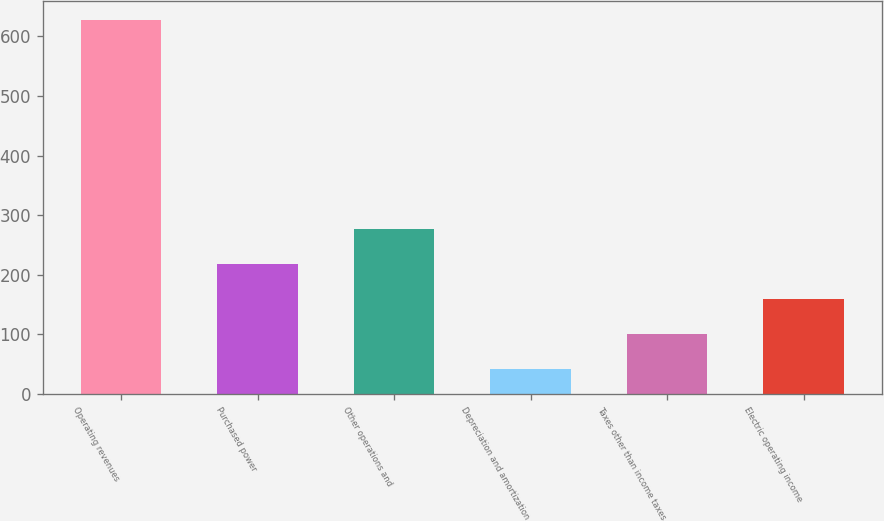Convert chart to OTSL. <chart><loc_0><loc_0><loc_500><loc_500><bar_chart><fcel>Operating revenues<fcel>Purchased power<fcel>Other operations and<fcel>Depreciation and amortization<fcel>Taxes other than income taxes<fcel>Electric operating income<nl><fcel>628<fcel>217.1<fcel>275.8<fcel>41<fcel>99.7<fcel>158.4<nl></chart> 